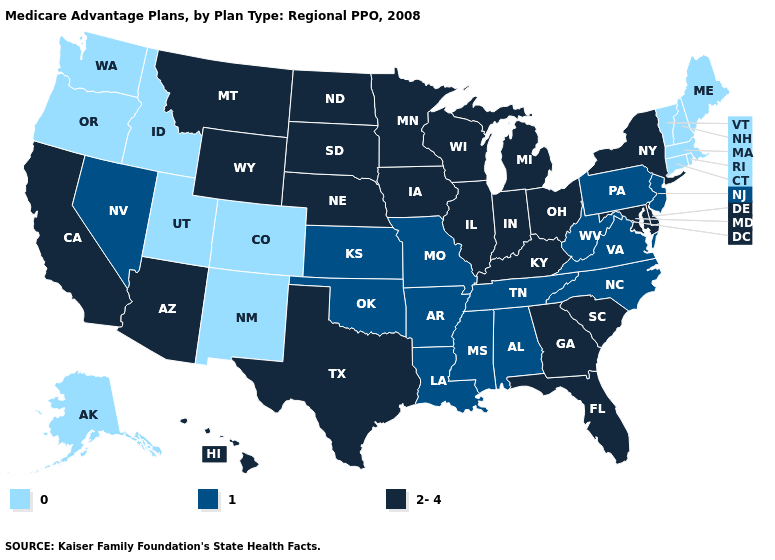Does Wyoming have a higher value than Minnesota?
Be succinct. No. Does Montana have the lowest value in the USA?
Concise answer only. No. Among the states that border Georgia , does Florida have the lowest value?
Keep it brief. No. Name the states that have a value in the range 0?
Quick response, please. Alaska, Colorado, Connecticut, Idaho, Massachusetts, Maine, New Hampshire, New Mexico, Oregon, Rhode Island, Utah, Vermont, Washington. What is the lowest value in the USA?
Write a very short answer. 0. Name the states that have a value in the range 0?
Give a very brief answer. Alaska, Colorado, Connecticut, Idaho, Massachusetts, Maine, New Hampshire, New Mexico, Oregon, Rhode Island, Utah, Vermont, Washington. Does Oklahoma have the same value as South Dakota?
Answer briefly. No. Name the states that have a value in the range 0?
Keep it brief. Alaska, Colorado, Connecticut, Idaho, Massachusetts, Maine, New Hampshire, New Mexico, Oregon, Rhode Island, Utah, Vermont, Washington. Does the first symbol in the legend represent the smallest category?
Short answer required. Yes. Does New Jersey have the highest value in the USA?
Quick response, please. No. What is the value of Tennessee?
Short answer required. 1. What is the lowest value in states that border Michigan?
Write a very short answer. 2-4. How many symbols are there in the legend?
Write a very short answer. 3. What is the value of Delaware?
Quick response, please. 2-4. Which states have the lowest value in the Northeast?
Be succinct. Connecticut, Massachusetts, Maine, New Hampshire, Rhode Island, Vermont. 